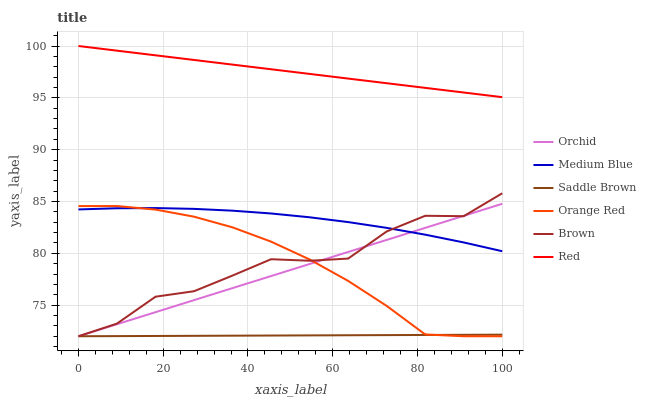Does Saddle Brown have the minimum area under the curve?
Answer yes or no. Yes. Does Red have the maximum area under the curve?
Answer yes or no. Yes. Does Medium Blue have the minimum area under the curve?
Answer yes or no. No. Does Medium Blue have the maximum area under the curve?
Answer yes or no. No. Is Orchid the smoothest?
Answer yes or no. Yes. Is Brown the roughest?
Answer yes or no. Yes. Is Medium Blue the smoothest?
Answer yes or no. No. Is Medium Blue the roughest?
Answer yes or no. No. Does Medium Blue have the lowest value?
Answer yes or no. No. Does Medium Blue have the highest value?
Answer yes or no. No. Is Orchid less than Red?
Answer yes or no. Yes. Is Red greater than Medium Blue?
Answer yes or no. Yes. Does Orchid intersect Red?
Answer yes or no. No. 